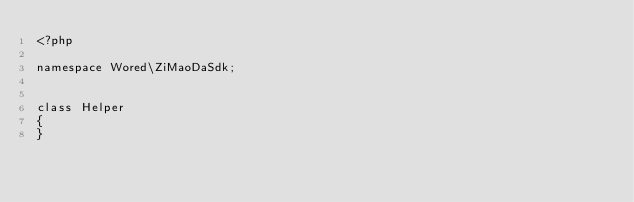Convert code to text. <code><loc_0><loc_0><loc_500><loc_500><_PHP_><?php

namespace Wored\ZiMaoDaSdk;


class Helper
{
}</code> 